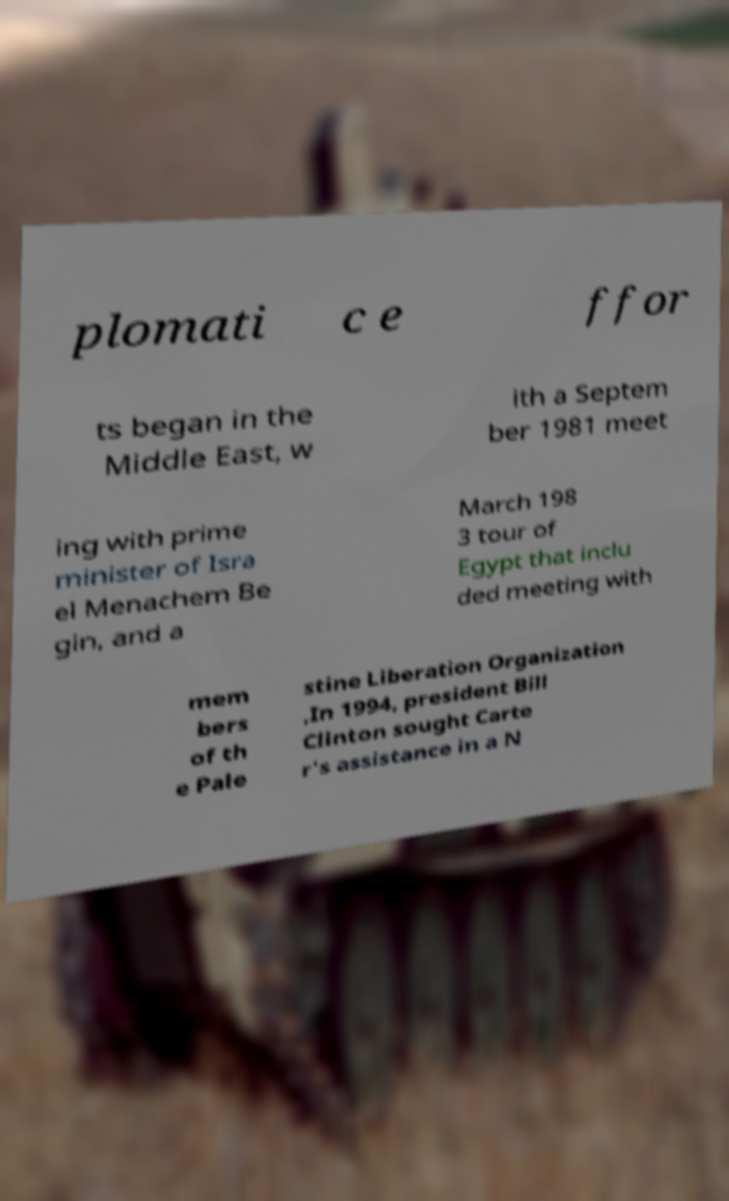There's text embedded in this image that I need extracted. Can you transcribe it verbatim? plomati c e ffor ts began in the Middle East, w ith a Septem ber 1981 meet ing with prime minister of Isra el Menachem Be gin, and a March 198 3 tour of Egypt that inclu ded meeting with mem bers of th e Pale stine Liberation Organization ,In 1994, president Bill Clinton sought Carte r's assistance in a N 